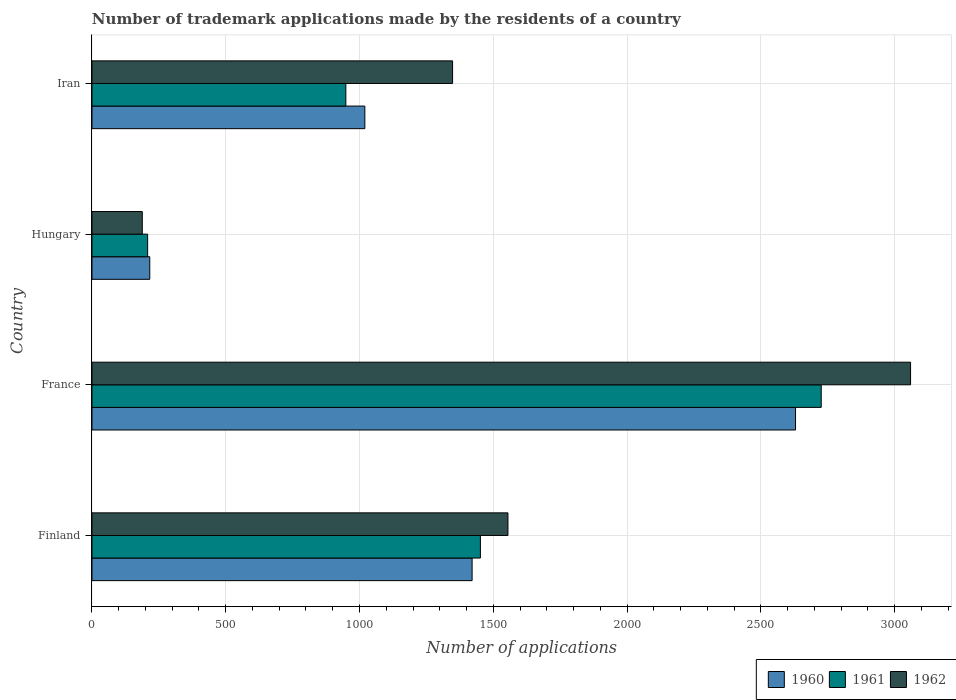Are the number of bars on each tick of the Y-axis equal?
Your response must be concise. Yes. How many bars are there on the 3rd tick from the bottom?
Your answer should be compact. 3. What is the label of the 1st group of bars from the top?
Provide a succinct answer. Iran. In how many cases, is the number of bars for a given country not equal to the number of legend labels?
Offer a terse response. 0. What is the number of trademark applications made by the residents in 1961 in France?
Make the answer very short. 2726. Across all countries, what is the maximum number of trademark applications made by the residents in 1962?
Your response must be concise. 3060. Across all countries, what is the minimum number of trademark applications made by the residents in 1960?
Offer a terse response. 216. In which country was the number of trademark applications made by the residents in 1961 maximum?
Give a very brief answer. France. In which country was the number of trademark applications made by the residents in 1962 minimum?
Ensure brevity in your answer.  Hungary. What is the total number of trademark applications made by the residents in 1962 in the graph?
Provide a short and direct response. 6151. What is the difference between the number of trademark applications made by the residents in 1960 in France and that in Iran?
Your answer should be very brief. 1610. What is the difference between the number of trademark applications made by the residents in 1960 in Hungary and the number of trademark applications made by the residents in 1962 in Iran?
Give a very brief answer. -1132. What is the average number of trademark applications made by the residents in 1961 per country?
Ensure brevity in your answer.  1333.75. What is the ratio of the number of trademark applications made by the residents in 1961 in France to that in Iran?
Make the answer very short. 2.87. Is the difference between the number of trademark applications made by the residents in 1960 in Finland and Iran greater than the difference between the number of trademark applications made by the residents in 1961 in Finland and Iran?
Make the answer very short. No. What is the difference between the highest and the second highest number of trademark applications made by the residents in 1962?
Offer a very short reply. 1505. What is the difference between the highest and the lowest number of trademark applications made by the residents in 1962?
Make the answer very short. 2872. Is the sum of the number of trademark applications made by the residents in 1961 in Finland and Hungary greater than the maximum number of trademark applications made by the residents in 1962 across all countries?
Your answer should be compact. No. Does the graph contain any zero values?
Offer a terse response. No. Does the graph contain grids?
Provide a succinct answer. Yes. Where does the legend appear in the graph?
Your answer should be compact. Bottom right. How are the legend labels stacked?
Your response must be concise. Horizontal. What is the title of the graph?
Your answer should be very brief. Number of trademark applications made by the residents of a country. What is the label or title of the X-axis?
Give a very brief answer. Number of applications. What is the Number of applications in 1960 in Finland?
Provide a succinct answer. 1421. What is the Number of applications of 1961 in Finland?
Provide a short and direct response. 1452. What is the Number of applications of 1962 in Finland?
Keep it short and to the point. 1555. What is the Number of applications in 1960 in France?
Ensure brevity in your answer.  2630. What is the Number of applications in 1961 in France?
Give a very brief answer. 2726. What is the Number of applications of 1962 in France?
Make the answer very short. 3060. What is the Number of applications in 1960 in Hungary?
Make the answer very short. 216. What is the Number of applications in 1961 in Hungary?
Provide a short and direct response. 208. What is the Number of applications in 1962 in Hungary?
Give a very brief answer. 188. What is the Number of applications in 1960 in Iran?
Give a very brief answer. 1020. What is the Number of applications in 1961 in Iran?
Offer a terse response. 949. What is the Number of applications in 1962 in Iran?
Give a very brief answer. 1348. Across all countries, what is the maximum Number of applications in 1960?
Offer a very short reply. 2630. Across all countries, what is the maximum Number of applications of 1961?
Your answer should be compact. 2726. Across all countries, what is the maximum Number of applications in 1962?
Offer a terse response. 3060. Across all countries, what is the minimum Number of applications in 1960?
Your answer should be compact. 216. Across all countries, what is the minimum Number of applications in 1961?
Ensure brevity in your answer.  208. Across all countries, what is the minimum Number of applications of 1962?
Your response must be concise. 188. What is the total Number of applications of 1960 in the graph?
Make the answer very short. 5287. What is the total Number of applications in 1961 in the graph?
Offer a very short reply. 5335. What is the total Number of applications of 1962 in the graph?
Provide a short and direct response. 6151. What is the difference between the Number of applications of 1960 in Finland and that in France?
Offer a terse response. -1209. What is the difference between the Number of applications in 1961 in Finland and that in France?
Keep it short and to the point. -1274. What is the difference between the Number of applications in 1962 in Finland and that in France?
Keep it short and to the point. -1505. What is the difference between the Number of applications of 1960 in Finland and that in Hungary?
Keep it short and to the point. 1205. What is the difference between the Number of applications in 1961 in Finland and that in Hungary?
Offer a terse response. 1244. What is the difference between the Number of applications of 1962 in Finland and that in Hungary?
Provide a short and direct response. 1367. What is the difference between the Number of applications in 1960 in Finland and that in Iran?
Your answer should be very brief. 401. What is the difference between the Number of applications in 1961 in Finland and that in Iran?
Keep it short and to the point. 503. What is the difference between the Number of applications in 1962 in Finland and that in Iran?
Ensure brevity in your answer.  207. What is the difference between the Number of applications of 1960 in France and that in Hungary?
Your answer should be very brief. 2414. What is the difference between the Number of applications in 1961 in France and that in Hungary?
Make the answer very short. 2518. What is the difference between the Number of applications of 1962 in France and that in Hungary?
Provide a succinct answer. 2872. What is the difference between the Number of applications of 1960 in France and that in Iran?
Your answer should be very brief. 1610. What is the difference between the Number of applications in 1961 in France and that in Iran?
Provide a short and direct response. 1777. What is the difference between the Number of applications in 1962 in France and that in Iran?
Give a very brief answer. 1712. What is the difference between the Number of applications of 1960 in Hungary and that in Iran?
Your response must be concise. -804. What is the difference between the Number of applications of 1961 in Hungary and that in Iran?
Provide a short and direct response. -741. What is the difference between the Number of applications in 1962 in Hungary and that in Iran?
Keep it short and to the point. -1160. What is the difference between the Number of applications of 1960 in Finland and the Number of applications of 1961 in France?
Keep it short and to the point. -1305. What is the difference between the Number of applications of 1960 in Finland and the Number of applications of 1962 in France?
Your response must be concise. -1639. What is the difference between the Number of applications in 1961 in Finland and the Number of applications in 1962 in France?
Keep it short and to the point. -1608. What is the difference between the Number of applications in 1960 in Finland and the Number of applications in 1961 in Hungary?
Provide a succinct answer. 1213. What is the difference between the Number of applications of 1960 in Finland and the Number of applications of 1962 in Hungary?
Provide a short and direct response. 1233. What is the difference between the Number of applications in 1961 in Finland and the Number of applications in 1962 in Hungary?
Make the answer very short. 1264. What is the difference between the Number of applications in 1960 in Finland and the Number of applications in 1961 in Iran?
Give a very brief answer. 472. What is the difference between the Number of applications in 1961 in Finland and the Number of applications in 1962 in Iran?
Offer a terse response. 104. What is the difference between the Number of applications in 1960 in France and the Number of applications in 1961 in Hungary?
Provide a succinct answer. 2422. What is the difference between the Number of applications in 1960 in France and the Number of applications in 1962 in Hungary?
Give a very brief answer. 2442. What is the difference between the Number of applications in 1961 in France and the Number of applications in 1962 in Hungary?
Offer a very short reply. 2538. What is the difference between the Number of applications in 1960 in France and the Number of applications in 1961 in Iran?
Provide a succinct answer. 1681. What is the difference between the Number of applications in 1960 in France and the Number of applications in 1962 in Iran?
Give a very brief answer. 1282. What is the difference between the Number of applications of 1961 in France and the Number of applications of 1962 in Iran?
Provide a succinct answer. 1378. What is the difference between the Number of applications in 1960 in Hungary and the Number of applications in 1961 in Iran?
Your response must be concise. -733. What is the difference between the Number of applications of 1960 in Hungary and the Number of applications of 1962 in Iran?
Ensure brevity in your answer.  -1132. What is the difference between the Number of applications of 1961 in Hungary and the Number of applications of 1962 in Iran?
Your answer should be very brief. -1140. What is the average Number of applications in 1960 per country?
Ensure brevity in your answer.  1321.75. What is the average Number of applications in 1961 per country?
Provide a short and direct response. 1333.75. What is the average Number of applications in 1962 per country?
Provide a short and direct response. 1537.75. What is the difference between the Number of applications of 1960 and Number of applications of 1961 in Finland?
Your answer should be very brief. -31. What is the difference between the Number of applications in 1960 and Number of applications in 1962 in Finland?
Your answer should be compact. -134. What is the difference between the Number of applications of 1961 and Number of applications of 1962 in Finland?
Offer a terse response. -103. What is the difference between the Number of applications in 1960 and Number of applications in 1961 in France?
Offer a very short reply. -96. What is the difference between the Number of applications in 1960 and Number of applications in 1962 in France?
Offer a very short reply. -430. What is the difference between the Number of applications of 1961 and Number of applications of 1962 in France?
Your answer should be very brief. -334. What is the difference between the Number of applications of 1961 and Number of applications of 1962 in Hungary?
Your response must be concise. 20. What is the difference between the Number of applications of 1960 and Number of applications of 1961 in Iran?
Offer a very short reply. 71. What is the difference between the Number of applications of 1960 and Number of applications of 1962 in Iran?
Offer a very short reply. -328. What is the difference between the Number of applications of 1961 and Number of applications of 1962 in Iran?
Your response must be concise. -399. What is the ratio of the Number of applications in 1960 in Finland to that in France?
Your answer should be compact. 0.54. What is the ratio of the Number of applications in 1961 in Finland to that in France?
Ensure brevity in your answer.  0.53. What is the ratio of the Number of applications of 1962 in Finland to that in France?
Ensure brevity in your answer.  0.51. What is the ratio of the Number of applications of 1960 in Finland to that in Hungary?
Offer a very short reply. 6.58. What is the ratio of the Number of applications in 1961 in Finland to that in Hungary?
Your answer should be compact. 6.98. What is the ratio of the Number of applications of 1962 in Finland to that in Hungary?
Provide a succinct answer. 8.27. What is the ratio of the Number of applications in 1960 in Finland to that in Iran?
Keep it short and to the point. 1.39. What is the ratio of the Number of applications of 1961 in Finland to that in Iran?
Your answer should be very brief. 1.53. What is the ratio of the Number of applications of 1962 in Finland to that in Iran?
Make the answer very short. 1.15. What is the ratio of the Number of applications in 1960 in France to that in Hungary?
Your answer should be compact. 12.18. What is the ratio of the Number of applications in 1961 in France to that in Hungary?
Your response must be concise. 13.11. What is the ratio of the Number of applications in 1962 in France to that in Hungary?
Offer a terse response. 16.28. What is the ratio of the Number of applications in 1960 in France to that in Iran?
Ensure brevity in your answer.  2.58. What is the ratio of the Number of applications of 1961 in France to that in Iran?
Provide a succinct answer. 2.87. What is the ratio of the Number of applications in 1962 in France to that in Iran?
Keep it short and to the point. 2.27. What is the ratio of the Number of applications of 1960 in Hungary to that in Iran?
Make the answer very short. 0.21. What is the ratio of the Number of applications in 1961 in Hungary to that in Iran?
Your response must be concise. 0.22. What is the ratio of the Number of applications in 1962 in Hungary to that in Iran?
Give a very brief answer. 0.14. What is the difference between the highest and the second highest Number of applications in 1960?
Offer a terse response. 1209. What is the difference between the highest and the second highest Number of applications in 1961?
Your answer should be very brief. 1274. What is the difference between the highest and the second highest Number of applications of 1962?
Ensure brevity in your answer.  1505. What is the difference between the highest and the lowest Number of applications of 1960?
Ensure brevity in your answer.  2414. What is the difference between the highest and the lowest Number of applications in 1961?
Your answer should be compact. 2518. What is the difference between the highest and the lowest Number of applications in 1962?
Keep it short and to the point. 2872. 